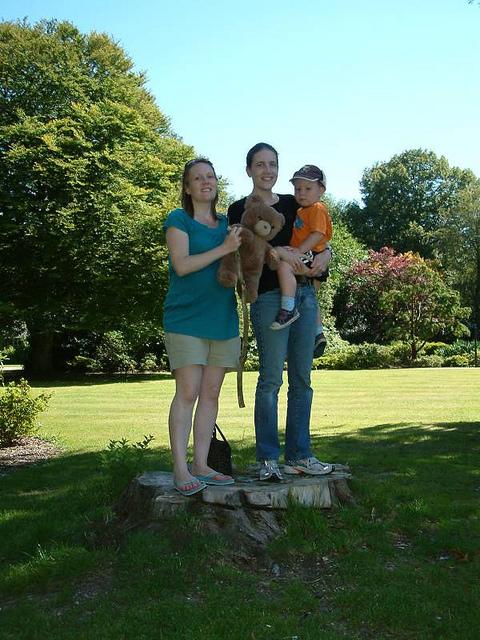What is in the man's hand?
Answer briefly. Child. Does the woman have thick thighs?
Quick response, please. No. Are the people in the picture standing on a rock?
Concise answer only. No. How many people are posing for the picture?
Concise answer only. 3. Is the boy wearing visor?
Be succinct. Yes. What are the people carrying?
Keep it brief. Teddy bear. 